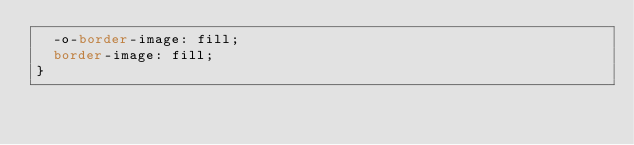<code> <loc_0><loc_0><loc_500><loc_500><_CSS_>  -o-border-image: fill;
  border-image: fill;
}
</code> 